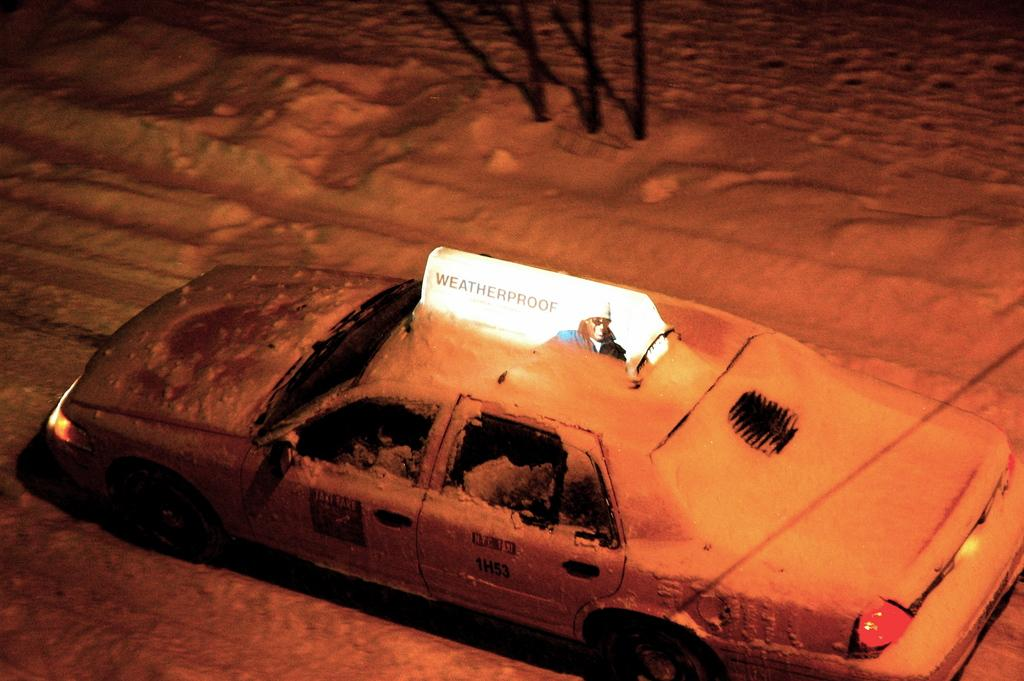<image>
Present a compact description of the photo's key features. A snowbound car with the illuminated word Weatherproof on the top. 